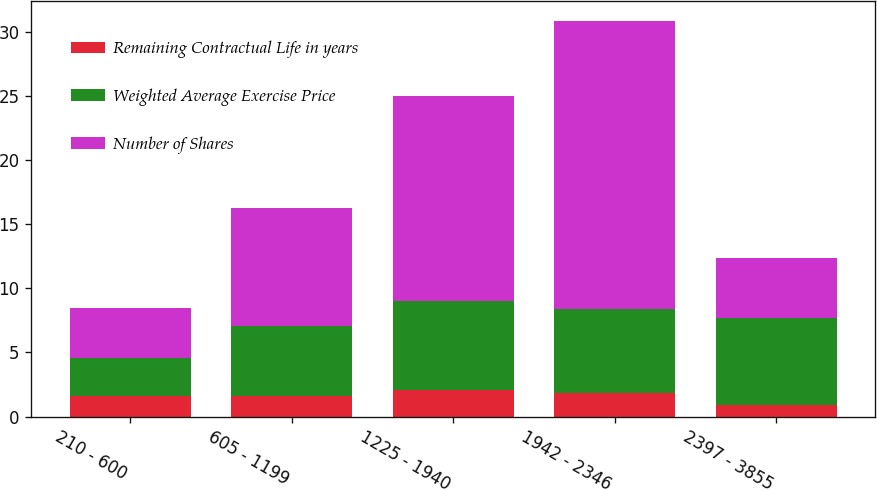<chart> <loc_0><loc_0><loc_500><loc_500><stacked_bar_chart><ecel><fcel>210 - 600<fcel>605 - 1199<fcel>1225 - 1940<fcel>1942 - 2346<fcel>2397 - 3855<nl><fcel>Remaining Contractual Life in years<fcel>1.6<fcel>1.6<fcel>2.1<fcel>1.8<fcel>0.9<nl><fcel>Weighted Average Exercise Price<fcel>2.97<fcel>5.46<fcel>6.91<fcel>6.59<fcel>6.77<nl><fcel>Number of Shares<fcel>3.92<fcel>9.18<fcel>15.95<fcel>22.45<fcel>4.69<nl></chart> 